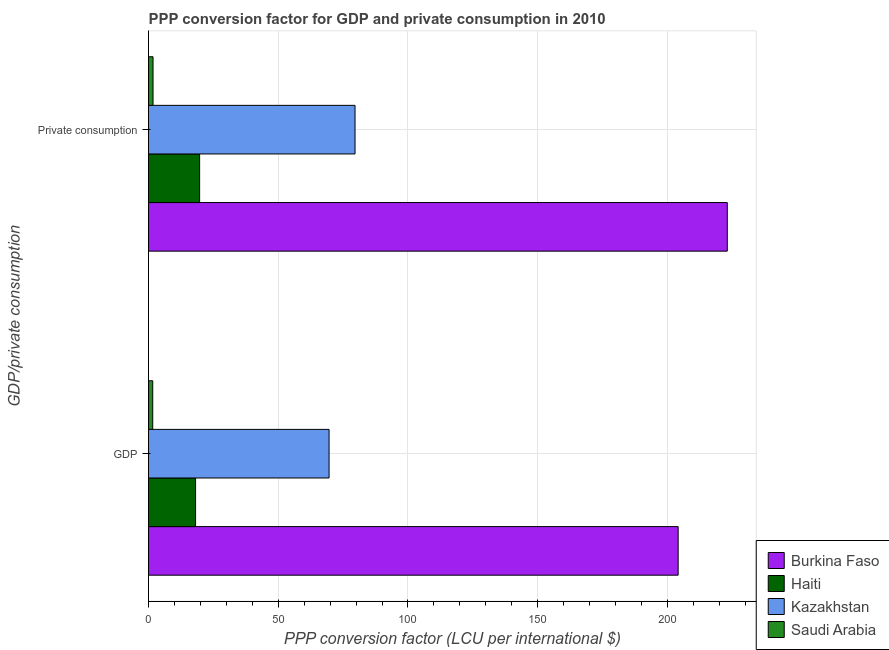Are the number of bars per tick equal to the number of legend labels?
Provide a short and direct response. Yes. How many bars are there on the 2nd tick from the top?
Offer a terse response. 4. How many bars are there on the 2nd tick from the bottom?
Give a very brief answer. 4. What is the label of the 1st group of bars from the top?
Make the answer very short.  Private consumption. What is the ppp conversion factor for private consumption in Saudi Arabia?
Offer a very short reply. 1.74. Across all countries, what is the maximum ppp conversion factor for private consumption?
Offer a very short reply. 223.1. Across all countries, what is the minimum ppp conversion factor for private consumption?
Offer a terse response. 1.74. In which country was the ppp conversion factor for gdp maximum?
Your response must be concise. Burkina Faso. In which country was the ppp conversion factor for private consumption minimum?
Make the answer very short. Saudi Arabia. What is the total ppp conversion factor for private consumption in the graph?
Keep it short and to the point. 324.15. What is the difference between the ppp conversion factor for private consumption in Kazakhstan and that in Haiti?
Provide a succinct answer. 59.9. What is the difference between the ppp conversion factor for private consumption in Kazakhstan and the ppp conversion factor for gdp in Saudi Arabia?
Provide a short and direct response. 77.98. What is the average ppp conversion factor for gdp per country?
Make the answer very short. 73.38. What is the difference between the ppp conversion factor for gdp and ppp conversion factor for private consumption in Haiti?
Offer a very short reply. -1.56. In how many countries, is the ppp conversion factor for gdp greater than 170 LCU?
Your answer should be compact. 1. What is the ratio of the ppp conversion factor for private consumption in Kazakhstan to that in Burkina Faso?
Keep it short and to the point. 0.36. Is the ppp conversion factor for gdp in Kazakhstan less than that in Saudi Arabia?
Provide a succinct answer. No. In how many countries, is the ppp conversion factor for gdp greater than the average ppp conversion factor for gdp taken over all countries?
Make the answer very short. 1. What does the 4th bar from the top in GDP represents?
Your answer should be compact. Burkina Faso. What does the 3rd bar from the bottom in  Private consumption represents?
Provide a short and direct response. Kazakhstan. How many bars are there?
Your response must be concise. 8. How many countries are there in the graph?
Your answer should be very brief. 4. What is the difference between two consecutive major ticks on the X-axis?
Give a very brief answer. 50. Are the values on the major ticks of X-axis written in scientific E-notation?
Offer a very short reply. No. How many legend labels are there?
Make the answer very short. 4. How are the legend labels stacked?
Your answer should be very brief. Vertical. What is the title of the graph?
Keep it short and to the point. PPP conversion factor for GDP and private consumption in 2010. Does "Latvia" appear as one of the legend labels in the graph?
Offer a terse response. No. What is the label or title of the X-axis?
Give a very brief answer. PPP conversion factor (LCU per international $). What is the label or title of the Y-axis?
Offer a terse response. GDP/private consumption. What is the PPP conversion factor (LCU per international $) in Burkina Faso in GDP?
Your response must be concise. 204.16. What is the PPP conversion factor (LCU per international $) of Haiti in GDP?
Offer a terse response. 18.14. What is the PPP conversion factor (LCU per international $) in Kazakhstan in GDP?
Provide a short and direct response. 69.6. What is the PPP conversion factor (LCU per international $) in Saudi Arabia in GDP?
Keep it short and to the point. 1.62. What is the PPP conversion factor (LCU per international $) of Burkina Faso in  Private consumption?
Your answer should be compact. 223.1. What is the PPP conversion factor (LCU per international $) in Haiti in  Private consumption?
Give a very brief answer. 19.7. What is the PPP conversion factor (LCU per international $) of Kazakhstan in  Private consumption?
Offer a terse response. 79.61. What is the PPP conversion factor (LCU per international $) in Saudi Arabia in  Private consumption?
Give a very brief answer. 1.74. Across all GDP/private consumption, what is the maximum PPP conversion factor (LCU per international $) in Burkina Faso?
Make the answer very short. 223.1. Across all GDP/private consumption, what is the maximum PPP conversion factor (LCU per international $) of Haiti?
Offer a terse response. 19.7. Across all GDP/private consumption, what is the maximum PPP conversion factor (LCU per international $) of Kazakhstan?
Your answer should be very brief. 79.61. Across all GDP/private consumption, what is the maximum PPP conversion factor (LCU per international $) in Saudi Arabia?
Ensure brevity in your answer.  1.74. Across all GDP/private consumption, what is the minimum PPP conversion factor (LCU per international $) in Burkina Faso?
Make the answer very short. 204.16. Across all GDP/private consumption, what is the minimum PPP conversion factor (LCU per international $) of Haiti?
Ensure brevity in your answer.  18.14. Across all GDP/private consumption, what is the minimum PPP conversion factor (LCU per international $) in Kazakhstan?
Ensure brevity in your answer.  69.6. Across all GDP/private consumption, what is the minimum PPP conversion factor (LCU per international $) of Saudi Arabia?
Provide a short and direct response. 1.62. What is the total PPP conversion factor (LCU per international $) of Burkina Faso in the graph?
Give a very brief answer. 427.27. What is the total PPP conversion factor (LCU per international $) in Haiti in the graph?
Keep it short and to the point. 37.84. What is the total PPP conversion factor (LCU per international $) in Kazakhstan in the graph?
Provide a short and direct response. 149.2. What is the total PPP conversion factor (LCU per international $) of Saudi Arabia in the graph?
Keep it short and to the point. 3.36. What is the difference between the PPP conversion factor (LCU per international $) in Burkina Faso in GDP and that in  Private consumption?
Your response must be concise. -18.94. What is the difference between the PPP conversion factor (LCU per international $) of Haiti in GDP and that in  Private consumption?
Ensure brevity in your answer.  -1.56. What is the difference between the PPP conversion factor (LCU per international $) of Kazakhstan in GDP and that in  Private consumption?
Keep it short and to the point. -10.01. What is the difference between the PPP conversion factor (LCU per international $) of Saudi Arabia in GDP and that in  Private consumption?
Offer a terse response. -0.12. What is the difference between the PPP conversion factor (LCU per international $) in Burkina Faso in GDP and the PPP conversion factor (LCU per international $) in Haiti in  Private consumption?
Offer a very short reply. 184.46. What is the difference between the PPP conversion factor (LCU per international $) of Burkina Faso in GDP and the PPP conversion factor (LCU per international $) of Kazakhstan in  Private consumption?
Provide a succinct answer. 124.56. What is the difference between the PPP conversion factor (LCU per international $) in Burkina Faso in GDP and the PPP conversion factor (LCU per international $) in Saudi Arabia in  Private consumption?
Offer a terse response. 202.42. What is the difference between the PPP conversion factor (LCU per international $) in Haiti in GDP and the PPP conversion factor (LCU per international $) in Kazakhstan in  Private consumption?
Make the answer very short. -61.46. What is the difference between the PPP conversion factor (LCU per international $) in Haiti in GDP and the PPP conversion factor (LCU per international $) in Saudi Arabia in  Private consumption?
Give a very brief answer. 16.4. What is the difference between the PPP conversion factor (LCU per international $) in Kazakhstan in GDP and the PPP conversion factor (LCU per international $) in Saudi Arabia in  Private consumption?
Offer a terse response. 67.86. What is the average PPP conversion factor (LCU per international $) in Burkina Faso per GDP/private consumption?
Provide a succinct answer. 213.63. What is the average PPP conversion factor (LCU per international $) of Haiti per GDP/private consumption?
Provide a succinct answer. 18.92. What is the average PPP conversion factor (LCU per international $) of Kazakhstan per GDP/private consumption?
Provide a short and direct response. 74.6. What is the average PPP conversion factor (LCU per international $) in Saudi Arabia per GDP/private consumption?
Ensure brevity in your answer.  1.68. What is the difference between the PPP conversion factor (LCU per international $) in Burkina Faso and PPP conversion factor (LCU per international $) in Haiti in GDP?
Your response must be concise. 186.02. What is the difference between the PPP conversion factor (LCU per international $) in Burkina Faso and PPP conversion factor (LCU per international $) in Kazakhstan in GDP?
Provide a succinct answer. 134.57. What is the difference between the PPP conversion factor (LCU per international $) in Burkina Faso and PPP conversion factor (LCU per international $) in Saudi Arabia in GDP?
Your answer should be very brief. 202.54. What is the difference between the PPP conversion factor (LCU per international $) of Haiti and PPP conversion factor (LCU per international $) of Kazakhstan in GDP?
Keep it short and to the point. -51.46. What is the difference between the PPP conversion factor (LCU per international $) in Haiti and PPP conversion factor (LCU per international $) in Saudi Arabia in GDP?
Provide a succinct answer. 16.52. What is the difference between the PPP conversion factor (LCU per international $) of Kazakhstan and PPP conversion factor (LCU per international $) of Saudi Arabia in GDP?
Offer a terse response. 67.98. What is the difference between the PPP conversion factor (LCU per international $) of Burkina Faso and PPP conversion factor (LCU per international $) of Haiti in  Private consumption?
Your answer should be compact. 203.4. What is the difference between the PPP conversion factor (LCU per international $) in Burkina Faso and PPP conversion factor (LCU per international $) in Kazakhstan in  Private consumption?
Offer a terse response. 143.5. What is the difference between the PPP conversion factor (LCU per international $) in Burkina Faso and PPP conversion factor (LCU per international $) in Saudi Arabia in  Private consumption?
Ensure brevity in your answer.  221.36. What is the difference between the PPP conversion factor (LCU per international $) in Haiti and PPP conversion factor (LCU per international $) in Kazakhstan in  Private consumption?
Provide a short and direct response. -59.9. What is the difference between the PPP conversion factor (LCU per international $) of Haiti and PPP conversion factor (LCU per international $) of Saudi Arabia in  Private consumption?
Provide a succinct answer. 17.96. What is the difference between the PPP conversion factor (LCU per international $) in Kazakhstan and PPP conversion factor (LCU per international $) in Saudi Arabia in  Private consumption?
Make the answer very short. 77.86. What is the ratio of the PPP conversion factor (LCU per international $) of Burkina Faso in GDP to that in  Private consumption?
Provide a short and direct response. 0.92. What is the ratio of the PPP conversion factor (LCU per international $) of Haiti in GDP to that in  Private consumption?
Ensure brevity in your answer.  0.92. What is the ratio of the PPP conversion factor (LCU per international $) of Kazakhstan in GDP to that in  Private consumption?
Keep it short and to the point. 0.87. What is the ratio of the PPP conversion factor (LCU per international $) of Saudi Arabia in GDP to that in  Private consumption?
Ensure brevity in your answer.  0.93. What is the difference between the highest and the second highest PPP conversion factor (LCU per international $) in Burkina Faso?
Provide a short and direct response. 18.94. What is the difference between the highest and the second highest PPP conversion factor (LCU per international $) of Haiti?
Offer a terse response. 1.56. What is the difference between the highest and the second highest PPP conversion factor (LCU per international $) in Kazakhstan?
Your answer should be compact. 10.01. What is the difference between the highest and the second highest PPP conversion factor (LCU per international $) of Saudi Arabia?
Your response must be concise. 0.12. What is the difference between the highest and the lowest PPP conversion factor (LCU per international $) of Burkina Faso?
Provide a short and direct response. 18.94. What is the difference between the highest and the lowest PPP conversion factor (LCU per international $) in Haiti?
Your answer should be very brief. 1.56. What is the difference between the highest and the lowest PPP conversion factor (LCU per international $) of Kazakhstan?
Offer a terse response. 10.01. What is the difference between the highest and the lowest PPP conversion factor (LCU per international $) in Saudi Arabia?
Your response must be concise. 0.12. 